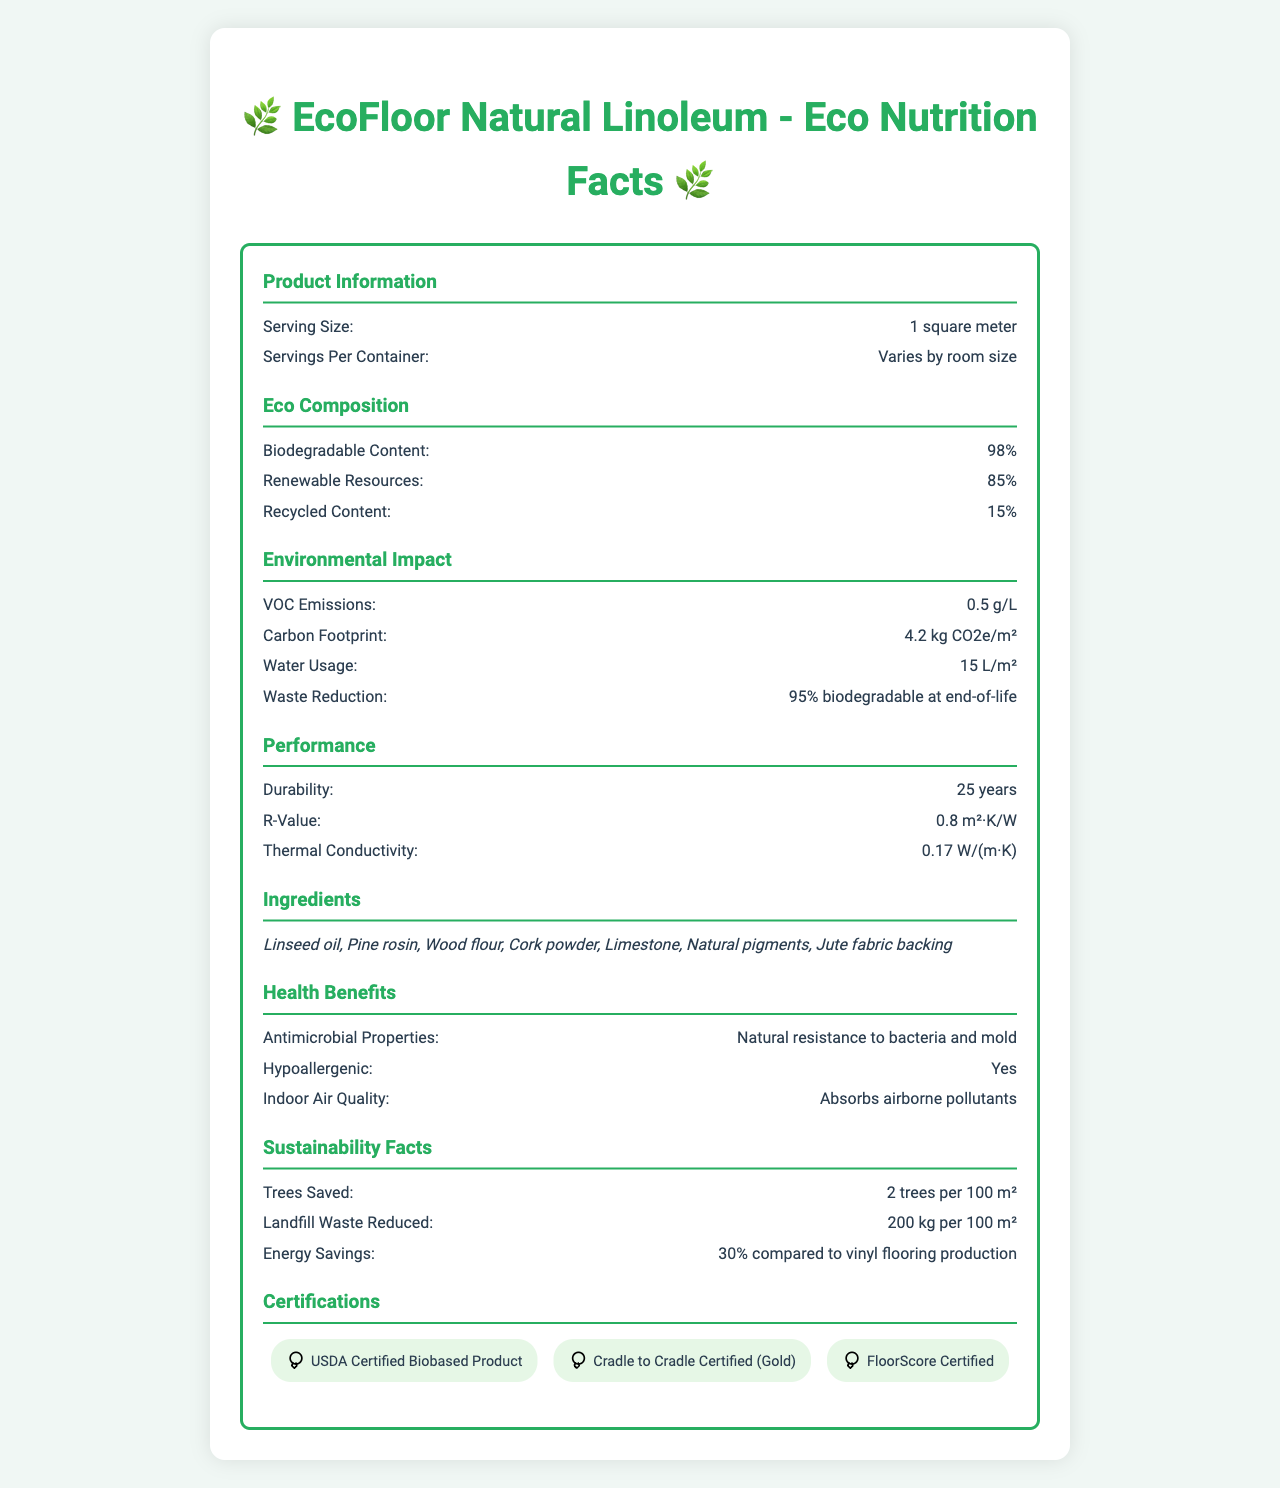what is the product name? The document indicates at the top that the product name is "EcoFloor Natural Linoleum".
Answer: EcoFloor Natural Linoleum what is the serving size of this product? Under the Product Information section, the serving size is mentioned as "1 square meter".
Answer: 1 square meter how many ingredients are listed for EcoFloor Natural Linoleum? The Ingredients section lists seven items: Linseed oil, Pine rosin, Wood flour, Cork powder, Limestone, Natural pigments, and Jute fabric backing.
Answer: 7 ingredients what is the durability of this flooring product? The Performance section notes that the durability of the product is 25 years.
Answer: 25 years how much water is used per square meter of this product? The Environmental Impact section specifies that the water usage is 15 liters per square meter.
Answer: 15 L/m² which of the following is NOT an ingredient in EcoFloor Natural Linoleum? A. Limestone B. Synthetic resin C. Wood flour D. Cork powder The Ingredients section lists Linseed oil, Pine rosin, Wood flour, Cork powder, Limestone, Natural pigments, and Jute fabric backing. Synthetic resin is not listed as an ingredient.
Answer: B. Synthetic resin how does the EcoFloor Natural Linoleum contribute to energy efficiency? A. Reduces heating costs B. Requires less energy to produce C. Increases insulation D. Reflects sunlight The Energy Efficiency section mentions the R-Value, which relates to the insulating properties of the material, indicating it increases insulation.
Answer: C. Increases insulation are there any harmful volatile organic compounds (VOCs) in this product? The VOC Emissions section shows that the product has VOC emissions of 0.5 g/L, which implies very low emissions.
Answer: No how many trees are saved per 100 square meters of EcoFloor Natural Linoleum? The Sustainability Facts section notes that two trees are saved per 100 square meters of flooring.
Answer: 2 trees per 100 m² is the EcoFloor Natural Linoleum certified by any environmental organizations? The Certifications section lists USDA Certified Biobased Product, Cradle to Cradle Certified (Gold), and FloorScore Certified.
Answer: Yes cannot the document be answered based on this: what is the price of EcoFloor Natural Linoleum? The document provides extensive details about the product but does not mention its price.
Answer: I don't know please summarize the main features and benefits of EcoFloor Natural Linoleum. The summary captures the key aspects highlighted in the document: its sustainability, performance, health benefits, certifications, and overall environmental impact. The detailed description is drawn from various sections of the document, giving a comprehensive overview.
Answer: EcoFloor Natural Linoleum is a sustainable flooring material with a high percentage of biodegradable and renewable resources. It is durable, energy-efficient, and has low VOC emissions. It contains natural ingredients and offers health benefits such as antimicrobial properties and hypoallergenic features. The product is certified by several environmental organizations, and its use contributes to significant sustainability advantages like saving trees and reducing landfill waste. 